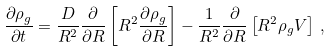Convert formula to latex. <formula><loc_0><loc_0><loc_500><loc_500>\frac { \partial \rho _ { g } } { \partial t } = \frac { D } { R ^ { 2 } } \frac { \partial } { \partial R } \left [ R ^ { 2 } \frac { \partial \rho _ { g } } { \partial R } \right ] - \frac { 1 } { R ^ { 2 } } \frac { \partial } { \partial R } \left [ R ^ { 2 } \rho _ { g } V \right ] \, ,</formula> 